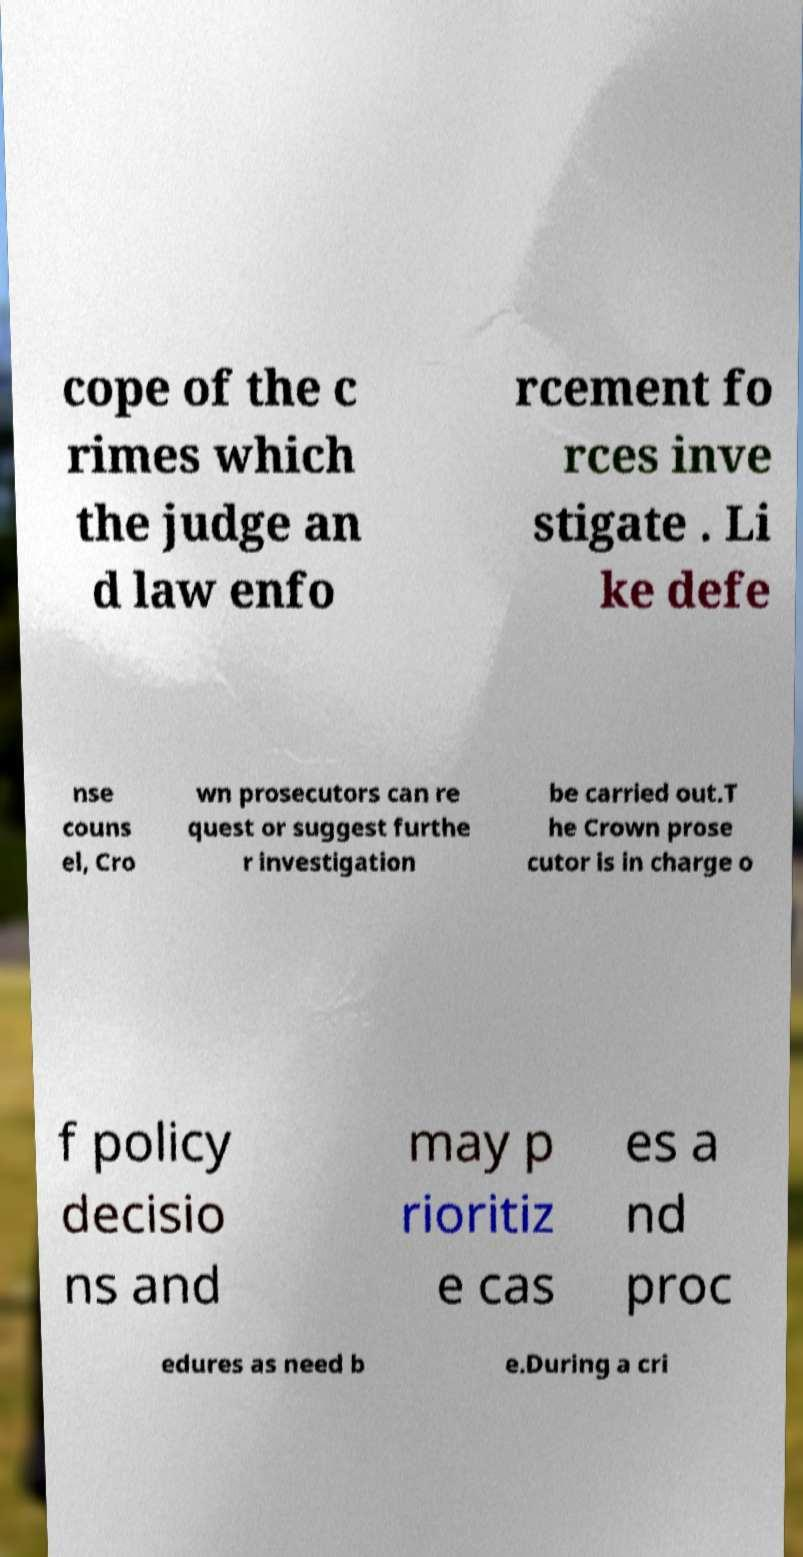There's text embedded in this image that I need extracted. Can you transcribe it verbatim? cope of the c rimes which the judge an d law enfo rcement fo rces inve stigate . Li ke defe nse couns el, Cro wn prosecutors can re quest or suggest furthe r investigation be carried out.T he Crown prose cutor is in charge o f policy decisio ns and may p rioritiz e cas es a nd proc edures as need b e.During a cri 